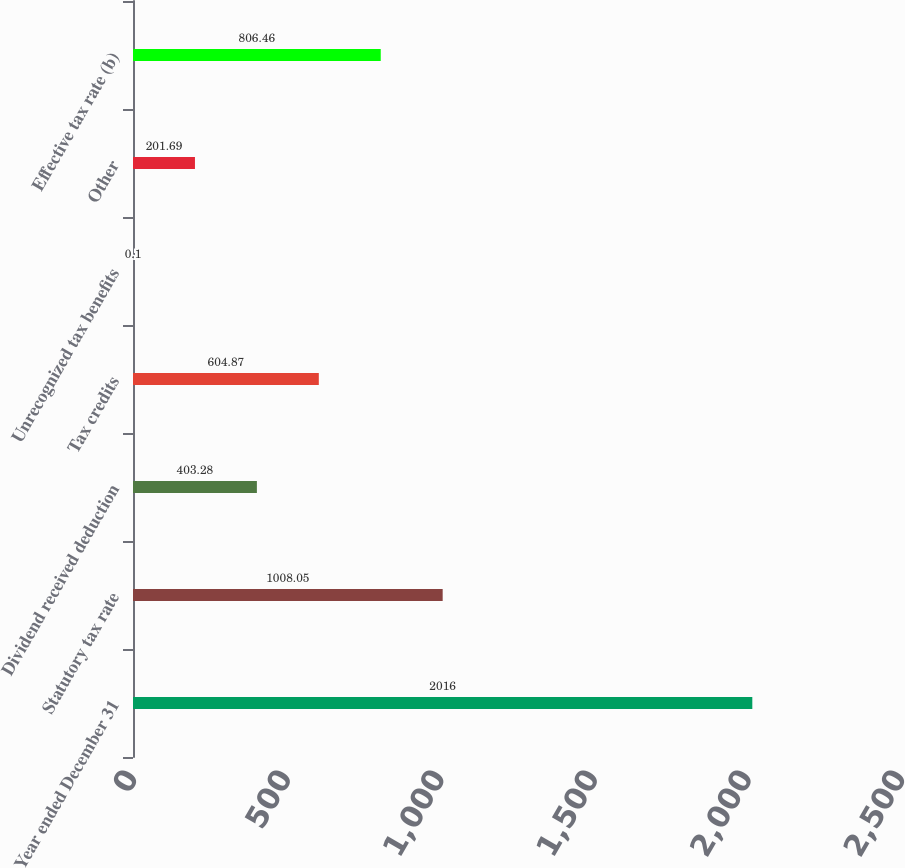<chart> <loc_0><loc_0><loc_500><loc_500><bar_chart><fcel>Year ended December 31<fcel>Statutory tax rate<fcel>Dividend received deduction<fcel>Tax credits<fcel>Unrecognized tax benefits<fcel>Other<fcel>Effective tax rate (b)<nl><fcel>2016<fcel>1008.05<fcel>403.28<fcel>604.87<fcel>0.1<fcel>201.69<fcel>806.46<nl></chart> 